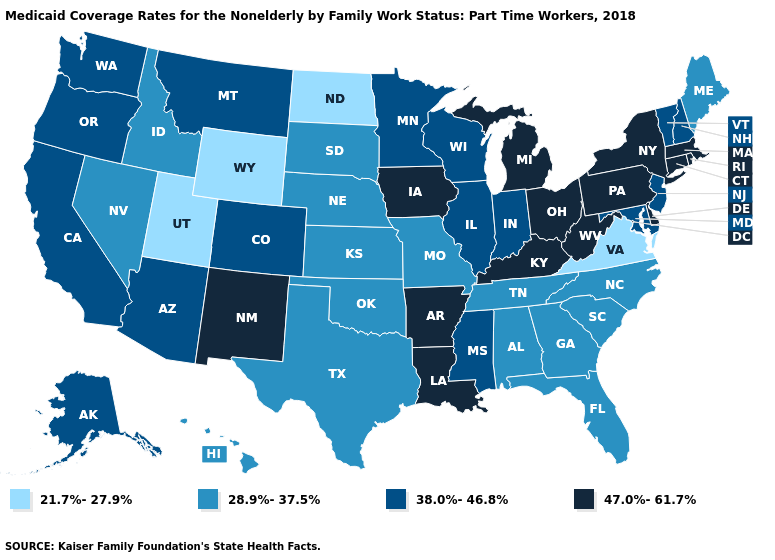Name the states that have a value in the range 47.0%-61.7%?
Keep it brief. Arkansas, Connecticut, Delaware, Iowa, Kentucky, Louisiana, Massachusetts, Michigan, New Mexico, New York, Ohio, Pennsylvania, Rhode Island, West Virginia. Name the states that have a value in the range 28.9%-37.5%?
Be succinct. Alabama, Florida, Georgia, Hawaii, Idaho, Kansas, Maine, Missouri, Nebraska, Nevada, North Carolina, Oklahoma, South Carolina, South Dakota, Tennessee, Texas. Which states have the lowest value in the West?
Short answer required. Utah, Wyoming. Name the states that have a value in the range 28.9%-37.5%?
Keep it brief. Alabama, Florida, Georgia, Hawaii, Idaho, Kansas, Maine, Missouri, Nebraska, Nevada, North Carolina, Oklahoma, South Carolina, South Dakota, Tennessee, Texas. What is the value of Nevada?
Be succinct. 28.9%-37.5%. What is the value of New Jersey?
Quick response, please. 38.0%-46.8%. Does Ohio have the highest value in the MidWest?
Write a very short answer. Yes. Name the states that have a value in the range 28.9%-37.5%?
Keep it brief. Alabama, Florida, Georgia, Hawaii, Idaho, Kansas, Maine, Missouri, Nebraska, Nevada, North Carolina, Oklahoma, South Carolina, South Dakota, Tennessee, Texas. Does Oregon have a lower value than Wisconsin?
Be succinct. No. What is the value of Arizona?
Quick response, please. 38.0%-46.8%. Among the states that border Illinois , which have the highest value?
Concise answer only. Iowa, Kentucky. Name the states that have a value in the range 38.0%-46.8%?
Write a very short answer. Alaska, Arizona, California, Colorado, Illinois, Indiana, Maryland, Minnesota, Mississippi, Montana, New Hampshire, New Jersey, Oregon, Vermont, Washington, Wisconsin. Which states have the lowest value in the Northeast?
Quick response, please. Maine. What is the highest value in states that border Minnesota?
Short answer required. 47.0%-61.7%. What is the value of Michigan?
Give a very brief answer. 47.0%-61.7%. 